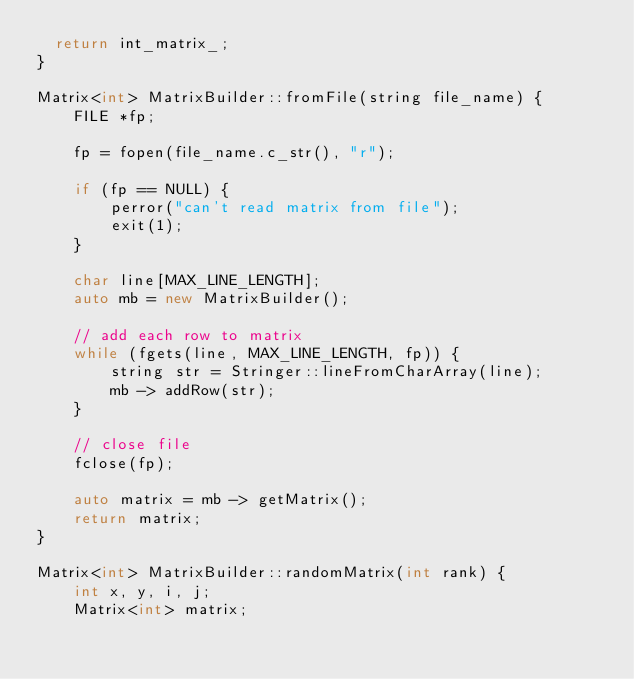Convert code to text. <code><loc_0><loc_0><loc_500><loc_500><_C++_>  return int_matrix_;
}

Matrix<int> MatrixBuilder::fromFile(string file_name) {
    FILE *fp;

    fp = fopen(file_name.c_str(), "r");

    if (fp == NULL) {
        perror("can't read matrix from file");
        exit(1);
    }

    char line[MAX_LINE_LENGTH];
    auto mb = new MatrixBuilder();

    // add each row to matrix
    while (fgets(line, MAX_LINE_LENGTH, fp)) {
        string str = Stringer::lineFromCharArray(line);
        mb -> addRow(str);
    }

    // close file
    fclose(fp);

    auto matrix = mb -> getMatrix();
    return matrix;
}

Matrix<int> MatrixBuilder::randomMatrix(int rank) {
    int x, y, i, j;
    Matrix<int> matrix;
</code> 